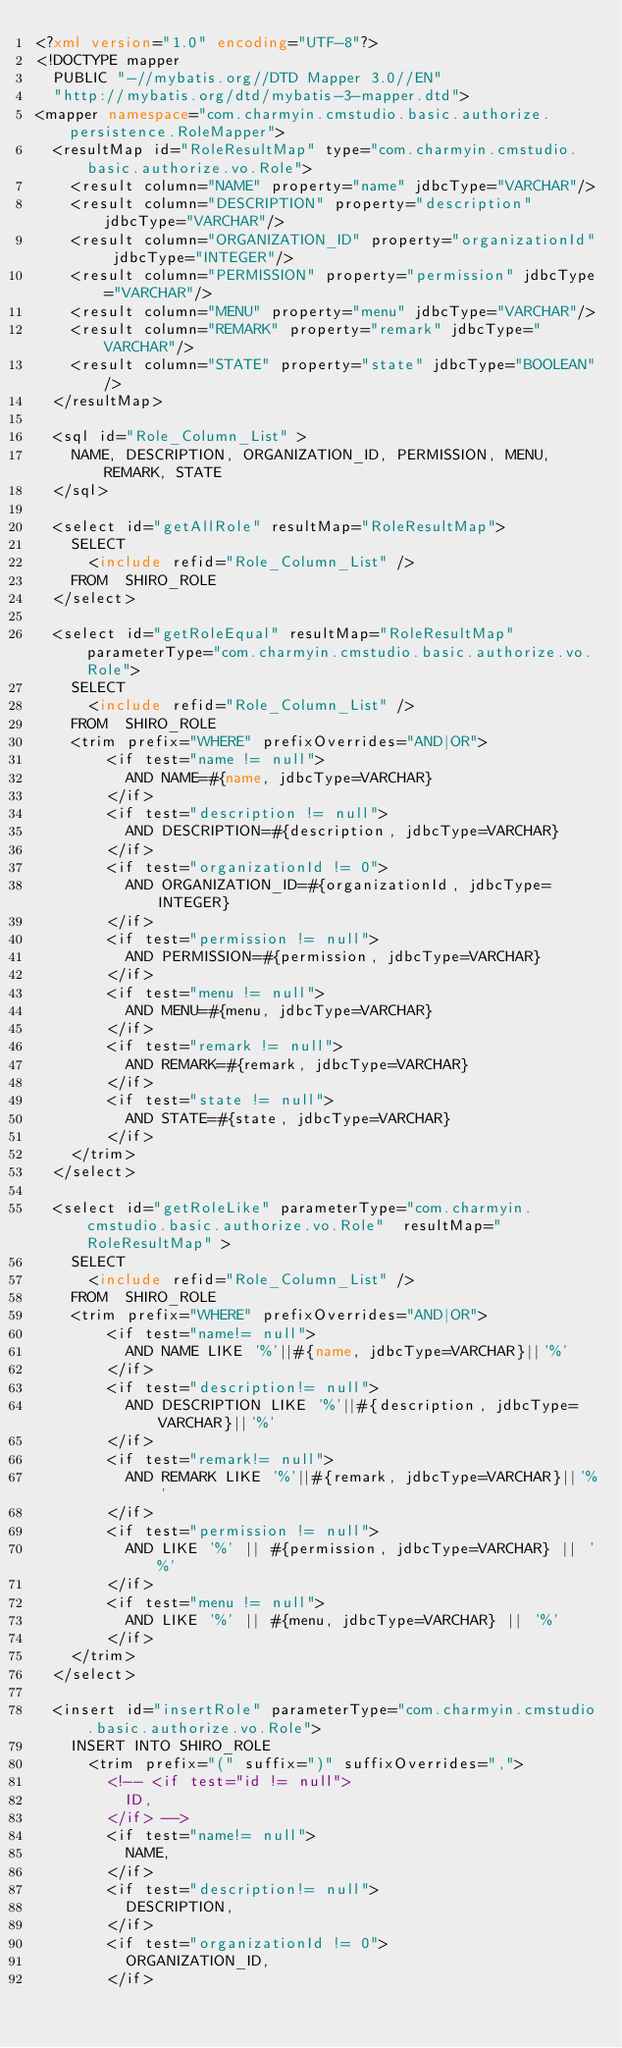Convert code to text. <code><loc_0><loc_0><loc_500><loc_500><_XML_><?xml version="1.0" encoding="UTF-8"?>
<!DOCTYPE mapper
  PUBLIC "-//mybatis.org//DTD Mapper 3.0//EN"
  "http://mybatis.org/dtd/mybatis-3-mapper.dtd">
<mapper namespace="com.charmyin.cmstudio.basic.authorize.persistence.RoleMapper">
	<resultMap id="RoleResultMap" type="com.charmyin.cmstudio.basic.authorize.vo.Role">
		<result column="NAME" property="name" jdbcType="VARCHAR"/>
		<result column="DESCRIPTION" property="description" jdbcType="VARCHAR"/>
		<result column="ORGANIZATION_ID" property="organizationId" jdbcType="INTEGER"/>
		<result column="PERMISSION" property="permission" jdbcType="VARCHAR"/>
		<result column="MENU" property="menu" jdbcType="VARCHAR"/>
		<result column="REMARK" property="remark" jdbcType="VARCHAR"/>
		<result column="STATE" property="state" jdbcType="BOOLEAN"/>
	</resultMap>

	<sql id="Role_Column_List" >
		NAME, DESCRIPTION, ORGANIZATION_ID, PERMISSION, MENU, REMARK, STATE
	</sql>
	
	<select id="getAllRole" resultMap="RoleResultMap">
		SELECT 
			<include refid="Role_Column_List" />
		FROM  SHIRO_ROLE
	</select>
	
	<select id="getRoleEqual" resultMap="RoleResultMap" parameterType="com.charmyin.cmstudio.basic.authorize.vo.Role">
		SELECT 
			<include refid="Role_Column_List" />
		FROM  SHIRO_ROLE
		<trim prefix="WHERE" prefixOverrides="AND|OR">
				<if test="name != null">
					AND NAME=#{name, jdbcType=VARCHAR}
				</if>
				<if test="description != null">
					AND DESCRIPTION=#{description, jdbcType=VARCHAR}
				</if>
				<if test="organizationId != 0">
					AND ORGANIZATION_ID=#{organizationId, jdbcType=INTEGER}
				</if>
				<if test="permission != null">
					AND PERMISSION=#{permission, jdbcType=VARCHAR}
				</if>
				<if test="menu != null">
					AND MENU=#{menu, jdbcType=VARCHAR}
				</if>
				<if test="remark != null">
					AND REMARK=#{remark, jdbcType=VARCHAR}
				</if>
				<if test="state != null">
					AND STATE=#{state, jdbcType=VARCHAR}
				</if>
		</trim>
	</select>
	
	<select id="getRoleLike" parameterType="com.charmyin.cmstudio.basic.authorize.vo.Role"  resultMap="RoleResultMap" >
		SELECT 
			<include refid="Role_Column_List" />
		FROM  SHIRO_ROLE
		<trim prefix="WHERE" prefixOverrides="AND|OR">
				<if test="name!= null">
					AND NAME LIKE '%'||#{name, jdbcType=VARCHAR}||'%'
				</if>
				<if test="description!= null">
					AND DESCRIPTION LIKE '%'||#{description, jdbcType=VARCHAR}||'%'
				</if>
				<if test="remark!= null">
					AND REMARK LIKE '%'||#{remark, jdbcType=VARCHAR}||'%'
				</if>
				<if test="permission != null">
					AND LIKE '%' || #{permission, jdbcType=VARCHAR} || '%'
				</if>
				<if test="menu != null">
					AND LIKE '%' || #{menu, jdbcType=VARCHAR} || '%'
				</if>
		</trim>
	</select>

	<insert id="insertRole" parameterType="com.charmyin.cmstudio.basic.authorize.vo.Role">
		INSERT INTO SHIRO_ROLE 
			<trim prefix="(" suffix=")" suffixOverrides=",">
				<!-- <if test="id != null">
					ID,
				</if> -->
				<if test="name!= null">
					NAME,
				</if>
				<if test="description!= null">
					DESCRIPTION,
				</if>
				<if test="organizationId != 0">
					ORGANIZATION_ID,
				</if></code> 